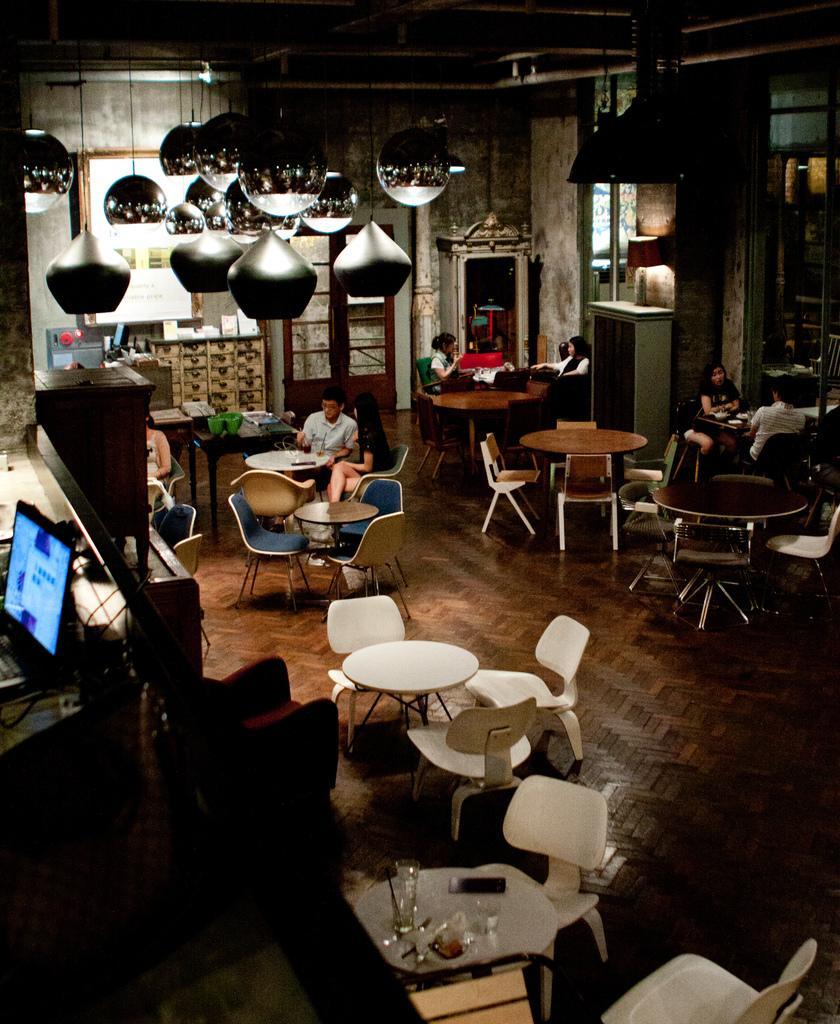Could you give a brief overview of what you see in this image? In this picture there is a glass, fork, spoon , phone on the table. There are chairs. There is a man and a woman sitting on a chair in the middle. There is a woman and a man sitting to the right. Two women sitting to the right. A green box is visible on the table. There is a laptop the the left. 